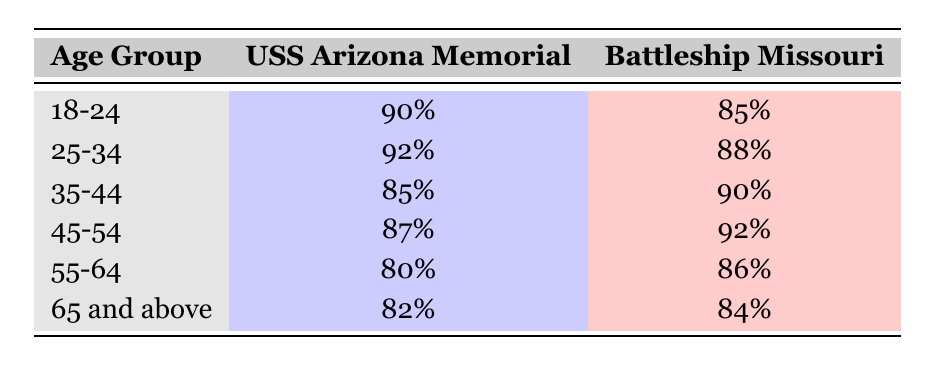What is the satisfaction rating for visitors aged 45-54 who visited the USS Arizona Memorial? According to the table, the satisfaction rating for the age group 45-54 visiting the USS Arizona Memorial is 87%.
Answer: 87% Which memorial do visitors aged 55-64 rate higher in satisfaction? The ratings for the age group 55-64 are 80% for the USS Arizona Memorial and 86% for the Battleship Missouri. Since 86% is higher than 80%, visitors aged 55-64 rate the Battleship Missouri higher.
Answer: Battleship Missouri What is the average satisfaction rating of the USS Arizona Memorial across all age groups? We need to sum up the satisfaction ratings from each age group for the USS Arizona Memorial: 90 + 92 + 85 + 87 + 80 + 82 = 516. There are 6 age groups, so we divide 516 by 6 to get an average of 86%.
Answer: 86% Do visitors aged 65 and above give a higher satisfaction rating to the USS Arizona Memorial than the Battleship Missouri? For the age group 65 and above, the satisfaction rating is 82% for the USS Arizona Memorial and 84% for the Battleship Missouri. Since 84% is higher, the statement is false.
Answer: No What is the difference in satisfaction ratings between the two memorials for visitors aged 35-44? The satisfaction rating for the USS Arizona Memorial in that age group is 85%, and for the Battleship Missouri, it is 90%. The difference is 90 - 85 = 5%.
Answer: 5% 